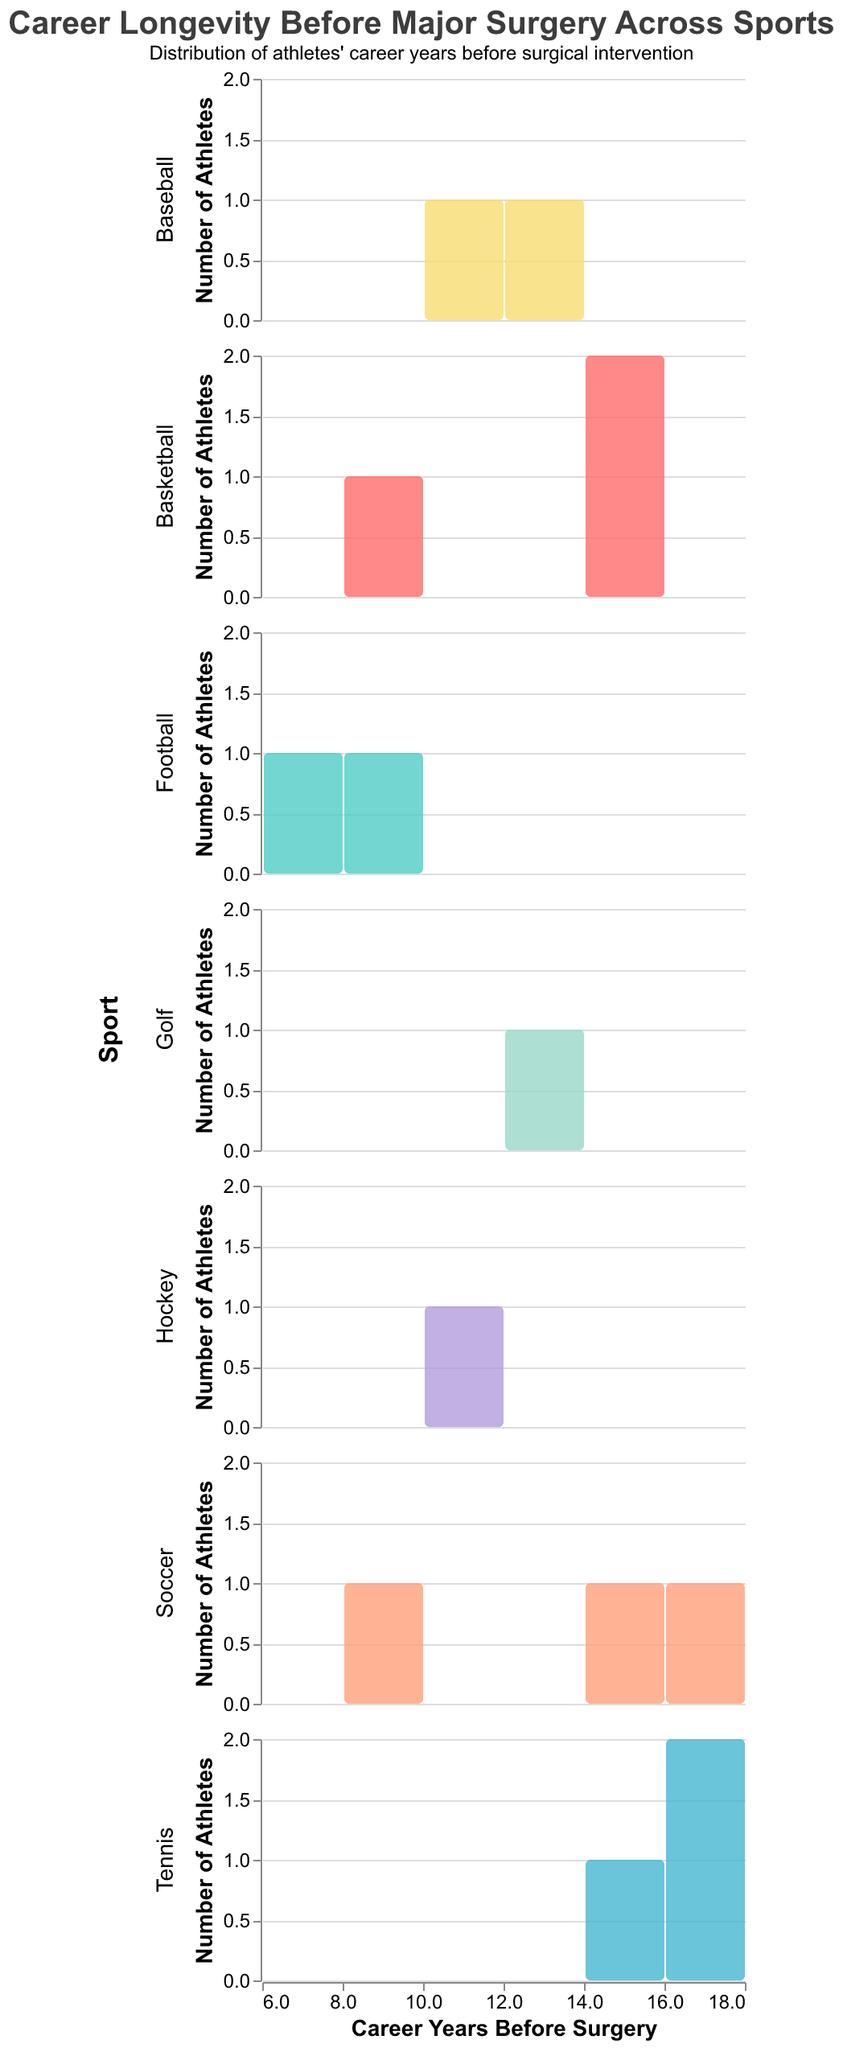How many athletes are shown in the 'Basketball' subplot? To find the number of athletes in the 'Basketball' subplot, count the data points labeled as 'Basketball' in the dataset. There are 3 basketball players: LeBron James, Kobe Bryant, and Kevin Durant.
Answer: 3 Which sport has the highest average career years before surgery? Calculate the average career years before surgery for each sport by summing the career years before surgery for each athlete in the sport and dividing by the number of athletes in that sport. Basketball: (15+14+9)/3 = 12.67, Football: (8+7)/2 = 7.5, Tennis: (16+18+14)/3 = 16, Soccer: (17+15+8)/3 = 13.33, Golf: 13, Baseball: (11+12)/2 = 11.5, Hockey: 10. Thus, Tennis has the highest average.
Answer: Tennis Does any sport have an athlete with exactly 5 career years before surgery? Check each subplot to see if there are any athletes with a career duration of exactly 5 years before surgery. Based on the data, no athlete has exactly 5 career years before surgery.
Answer: No Which sport shows the longest average career years after surgery? Calculate the average career years after surgery for each sport. For Basketball: (6+4+5)/3 = 5. For Football: (14+8)/2 = 11. For Tennis: (5+4+5)/3 = 4.67. For Soccer: (4+6+6)/3 = 5.33. For Golf: 7. For Baseball: (4+5)/2 = 4.5. For Hockey: 7. Football has the longest average career years after surgery.
Answer: Football Which athlete had the longest career span in years before undergoing surgery? Determine the maximum value in the 'Career_Years_Before_Surgery' column in the dataset. Cristiano Ronaldo had 17 years before surgery.
Answer: Cristiano Ronaldo What's the combined career years before surgery for all Tennis athletes? Sum the career years before surgery for all Tennis athletes (16+18+14). The calculation is 16 + 18 + 14 = 48.
Answer: 48 What is the difference in average career years before surgery between Soccer and Basketball? First, calculate the average for each sport. Soccer: (17+15+8)/3 ≈ 13.33. Basketball: (15+14+9)/3 ≈ 12.67. The difference is 13.33 - 12.67 ≈ 0.66.
Answer: 0.66 Which sport has the most diverse career longevity before surgery, based on the range of career years? Find the range (max - min) for each sport. Basketball: 15 - 9 = 6, Football: 8 - 7 = 1, Tennis: 18 - 14 = 4, Soccer: 17 - 8 = 9, Golf: 13 - 13 = 0, Baseball: 12 - 11 = 1, Hockey: 10 - 10 = 0. Soccer has the largest range at 9 years.
Answer: Soccer Can we see any trend between career longevity before and after surgery? Scan through the subplots and observe the general patterns. Many athletes have a shorter career span after surgery, indicating a trend where career longevity often decreases post-surgery.
Answer: Decreasing trend 